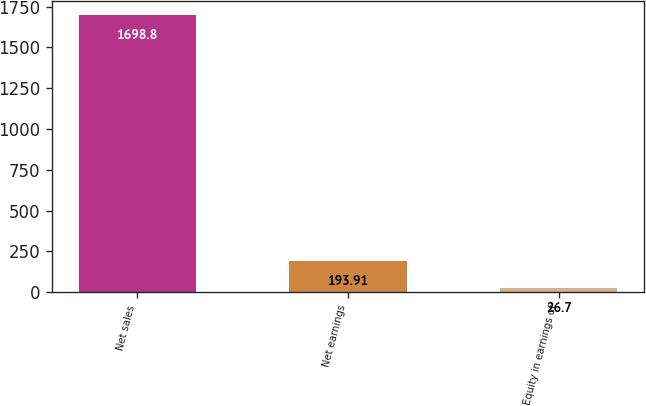Convert chart. <chart><loc_0><loc_0><loc_500><loc_500><bar_chart><fcel>Net sales<fcel>Net earnings<fcel>Equity in earnings of<nl><fcel>1698.8<fcel>193.91<fcel>26.7<nl></chart> 